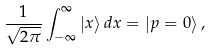<formula> <loc_0><loc_0><loc_500><loc_500>\frac { 1 } { \sqrt { 2 \pi } } \int _ { - \infty } ^ { \infty } \left | x \right \rangle d x = \left | p = 0 \right \rangle ,</formula> 